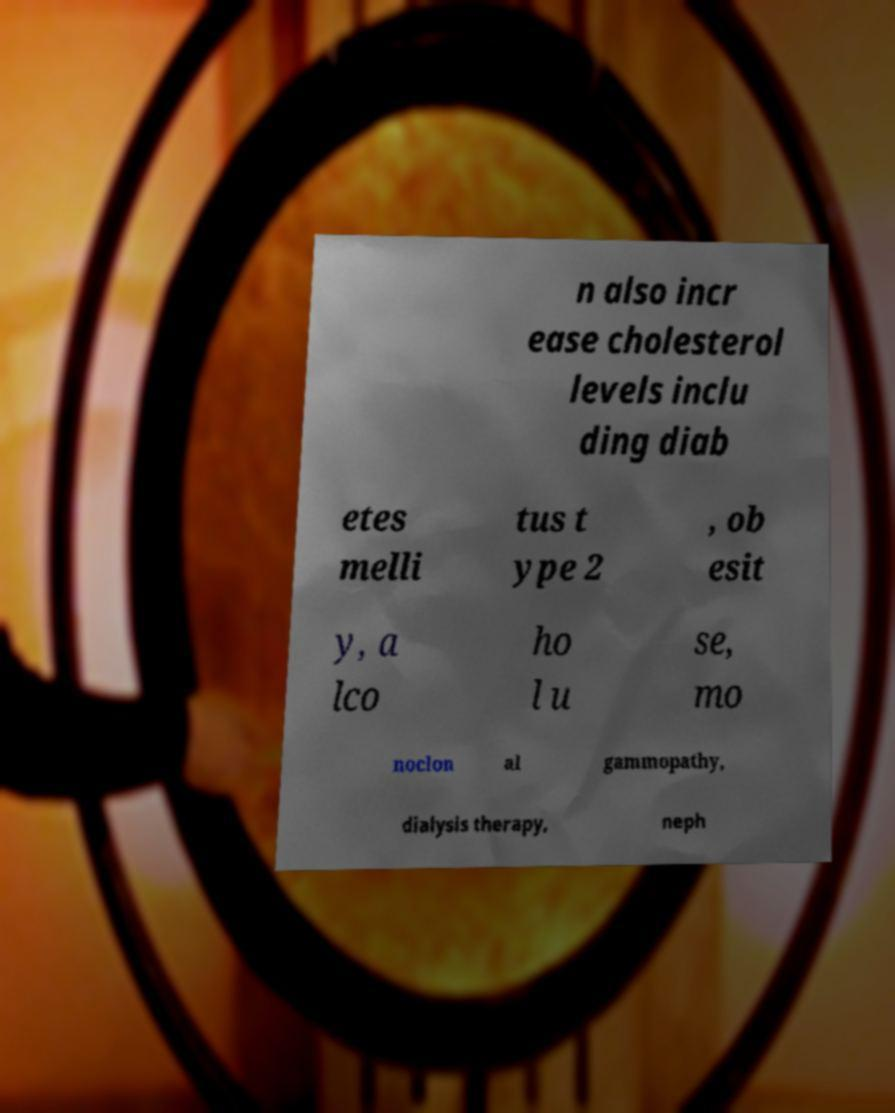Please identify and transcribe the text found in this image. n also incr ease cholesterol levels inclu ding diab etes melli tus t ype 2 , ob esit y, a lco ho l u se, mo noclon al gammopathy, dialysis therapy, neph 